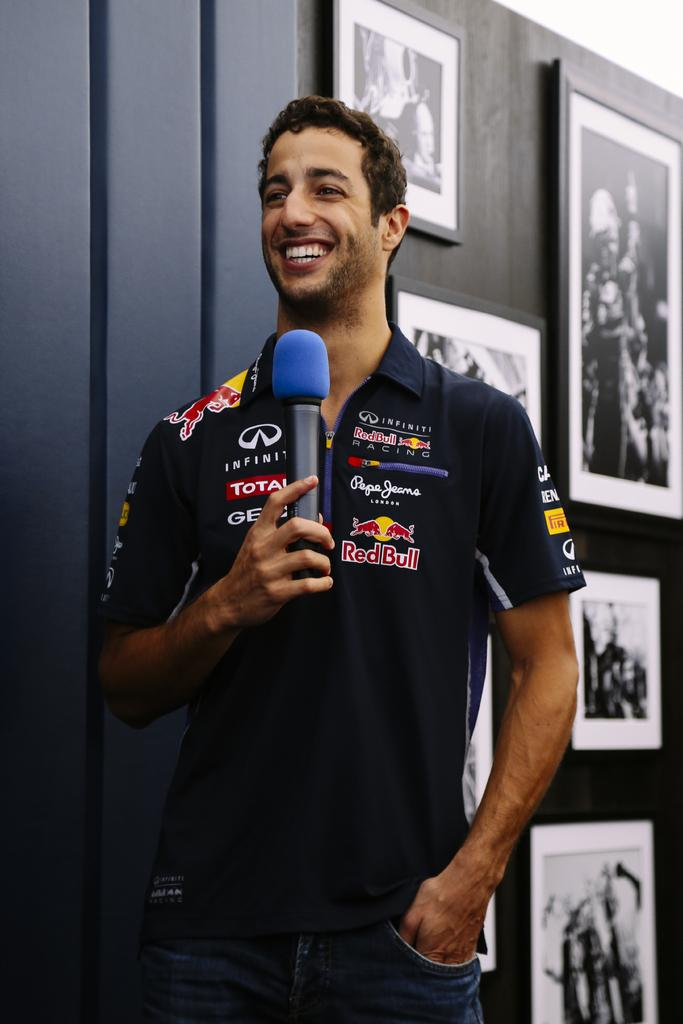<image>
Present a compact description of the photo's key features. A man with a microphone has a RedBull logo on his shirt. 